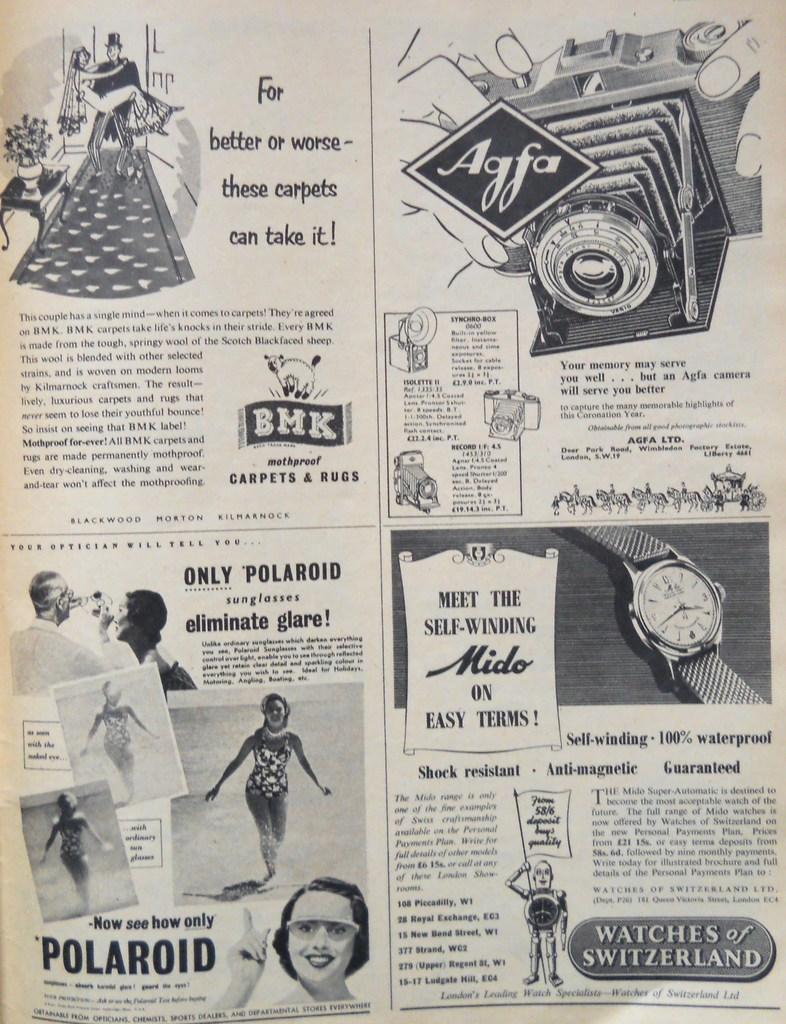Provide a one-sentence caption for the provided image. A newspaper ad featuring wool, mothproof carpets from BMK. 